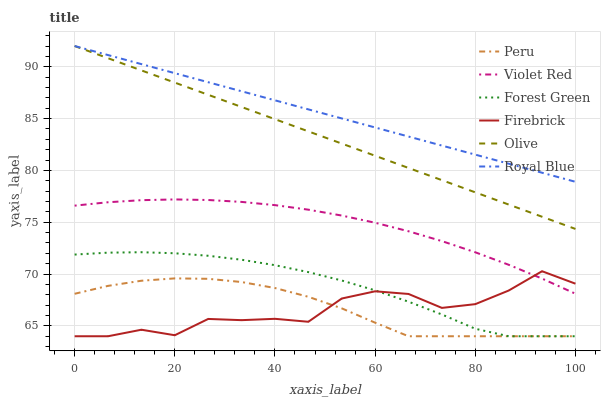Does Firebrick have the minimum area under the curve?
Answer yes or no. Yes. Does Royal Blue have the maximum area under the curve?
Answer yes or no. Yes. Does Royal Blue have the minimum area under the curve?
Answer yes or no. No. Does Firebrick have the maximum area under the curve?
Answer yes or no. No. Is Olive the smoothest?
Answer yes or no. Yes. Is Firebrick the roughest?
Answer yes or no. Yes. Is Royal Blue the smoothest?
Answer yes or no. No. Is Royal Blue the roughest?
Answer yes or no. No. Does Firebrick have the lowest value?
Answer yes or no. Yes. Does Royal Blue have the lowest value?
Answer yes or no. No. Does Olive have the highest value?
Answer yes or no. Yes. Does Firebrick have the highest value?
Answer yes or no. No. Is Peru less than Olive?
Answer yes or no. Yes. Is Violet Red greater than Peru?
Answer yes or no. Yes. Does Peru intersect Firebrick?
Answer yes or no. Yes. Is Peru less than Firebrick?
Answer yes or no. No. Is Peru greater than Firebrick?
Answer yes or no. No. Does Peru intersect Olive?
Answer yes or no. No. 